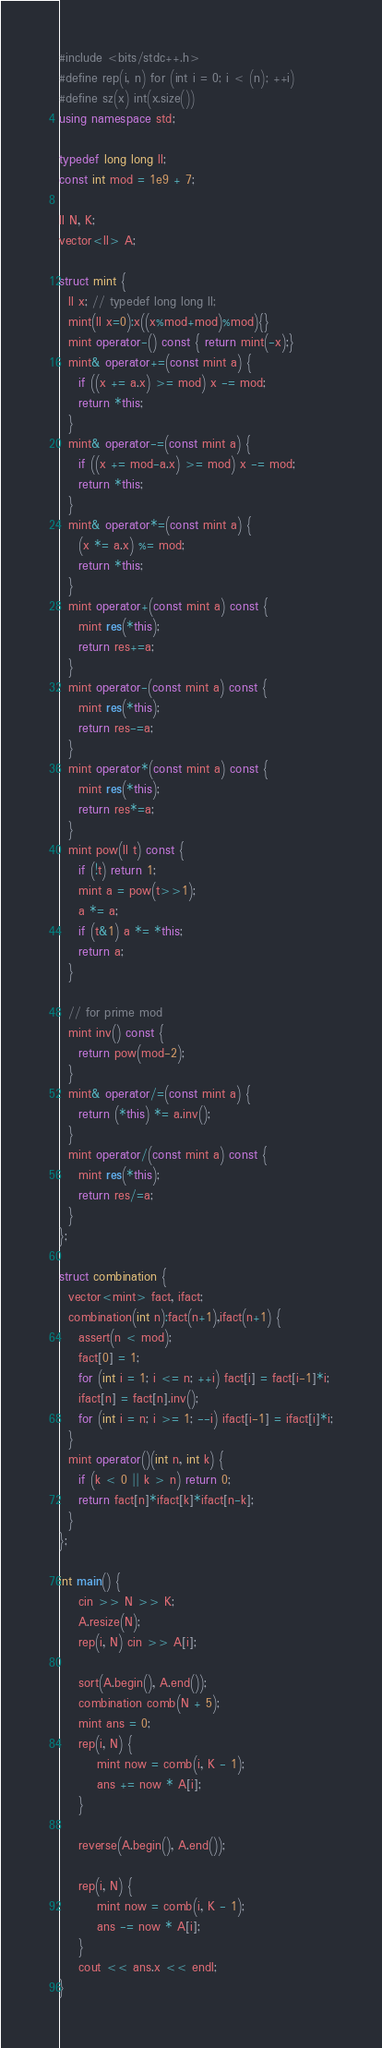<code> <loc_0><loc_0><loc_500><loc_500><_C++_>#include <bits/stdc++.h>
#define rep(i, n) for (int i = 0; i < (n); ++i)
#define sz(x) int(x.size())
using namespace std;

typedef long long ll;
const int mod = 1e9 + 7;

ll N, K;
vector<ll> A;

struct mint {
  ll x; // typedef long long ll;
  mint(ll x=0):x((x%mod+mod)%mod){}
  mint operator-() const { return mint(-x);}
  mint& operator+=(const mint a) {
    if ((x += a.x) >= mod) x -= mod;
    return *this;
  }
  mint& operator-=(const mint a) {
    if ((x += mod-a.x) >= mod) x -= mod;
    return *this;
  }
  mint& operator*=(const mint a) {
    (x *= a.x) %= mod;
    return *this;
  }
  mint operator+(const mint a) const {
    mint res(*this);
    return res+=a;
  }
  mint operator-(const mint a) const {
    mint res(*this);
    return res-=a;
  }
  mint operator*(const mint a) const {
    mint res(*this);
    return res*=a;
  }
  mint pow(ll t) const {
    if (!t) return 1;
    mint a = pow(t>>1);
    a *= a;
    if (t&1) a *= *this;
    return a;
  }

  // for prime mod
  mint inv() const {
    return pow(mod-2);
  }
  mint& operator/=(const mint a) {
    return (*this) *= a.inv();
  }
  mint operator/(const mint a) const {
    mint res(*this);
    return res/=a;
  }
};

struct combination {
  vector<mint> fact, ifact;
  combination(int n):fact(n+1),ifact(n+1) {
    assert(n < mod);
    fact[0] = 1;
    for (int i = 1; i <= n; ++i) fact[i] = fact[i-1]*i;
    ifact[n] = fact[n].inv();
    for (int i = n; i >= 1; --i) ifact[i-1] = ifact[i]*i;
  }
  mint operator()(int n, int k) {
    if (k < 0 || k > n) return 0;
    return fact[n]*ifact[k]*ifact[n-k];
  }
};

int main() {
    cin >> N >> K;
    A.resize(N);
    rep(i, N) cin >> A[i];

    sort(A.begin(), A.end());
    combination comb(N + 5);
    mint ans = 0;
    rep(i, N) {
        mint now = comb(i, K - 1);
        ans += now * A[i];
    }

    reverse(A.begin(), A.end());

    rep(i, N) {
        mint now = comb(i, K - 1);
        ans -= now * A[i];
    }
    cout << ans.x << endl;
}</code> 